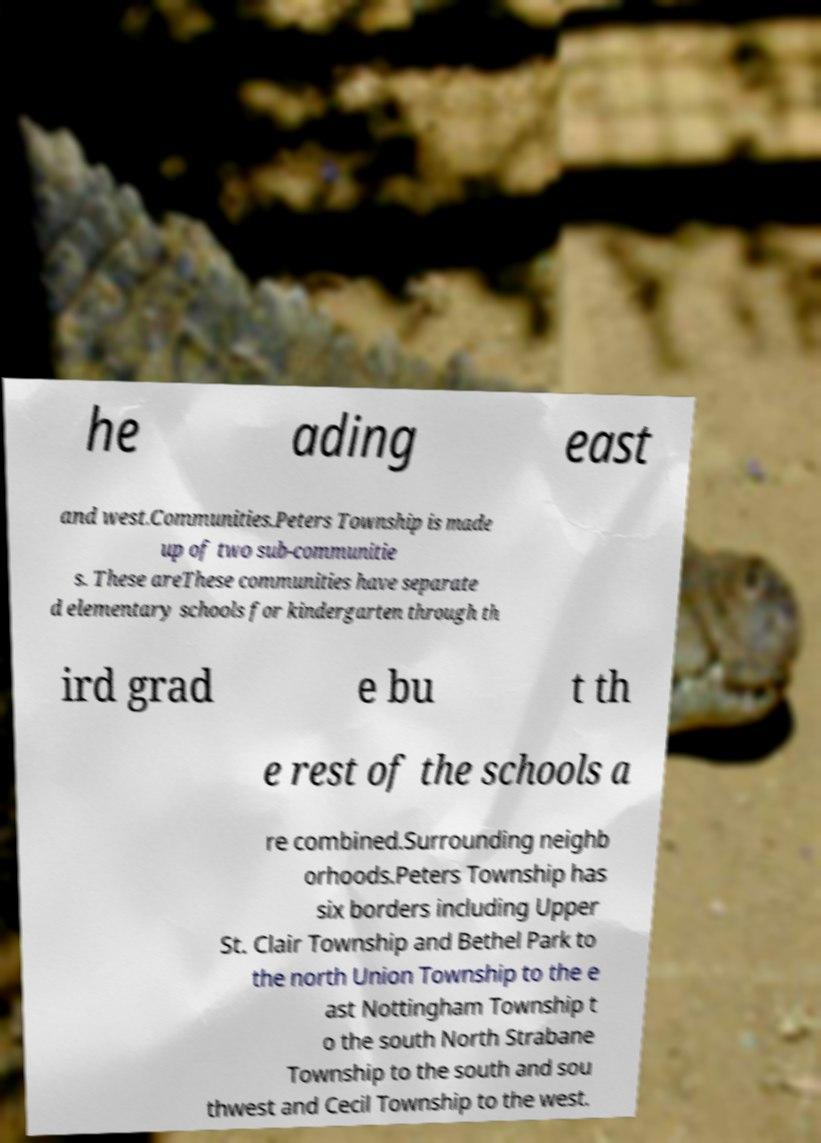What messages or text are displayed in this image? I need them in a readable, typed format. he ading east and west.Communities.Peters Township is made up of two sub-communitie s. These areThese communities have separate d elementary schools for kindergarten through th ird grad e bu t th e rest of the schools a re combined.Surrounding neighb orhoods.Peters Township has six borders including Upper St. Clair Township and Bethel Park to the north Union Township to the e ast Nottingham Township t o the south North Strabane Township to the south and sou thwest and Cecil Township to the west. 